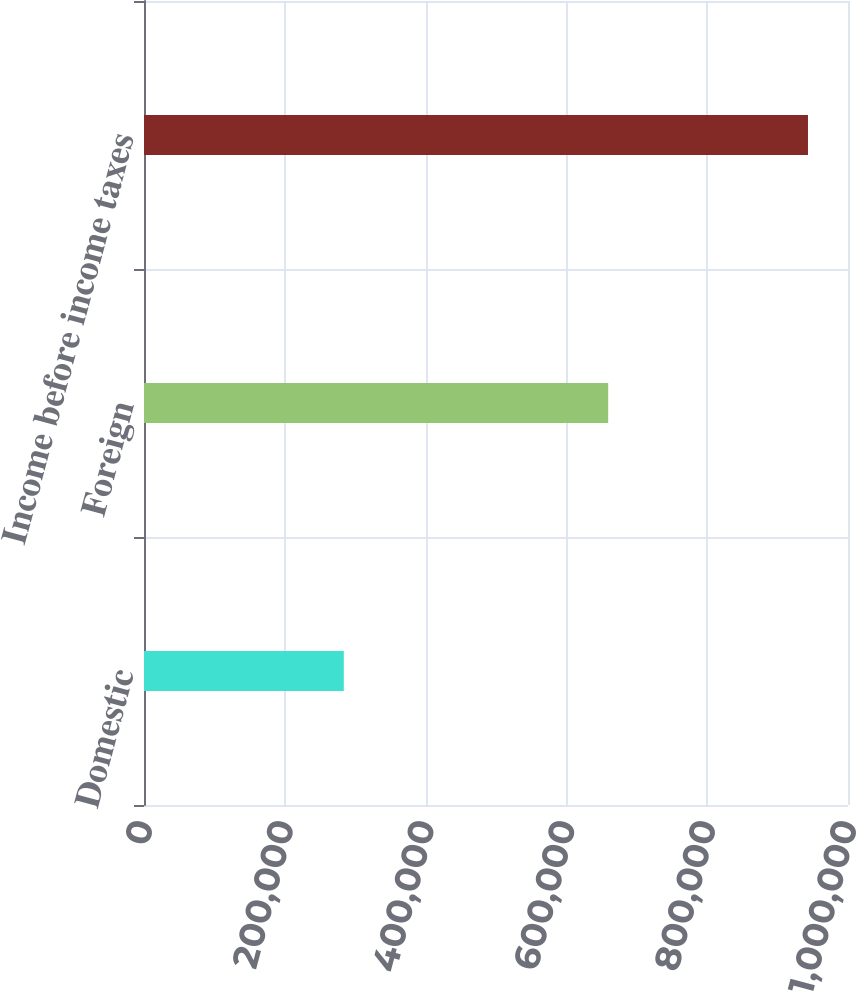<chart> <loc_0><loc_0><loc_500><loc_500><bar_chart><fcel>Domestic<fcel>Foreign<fcel>Income before income taxes<nl><fcel>283819<fcel>659332<fcel>943151<nl></chart> 